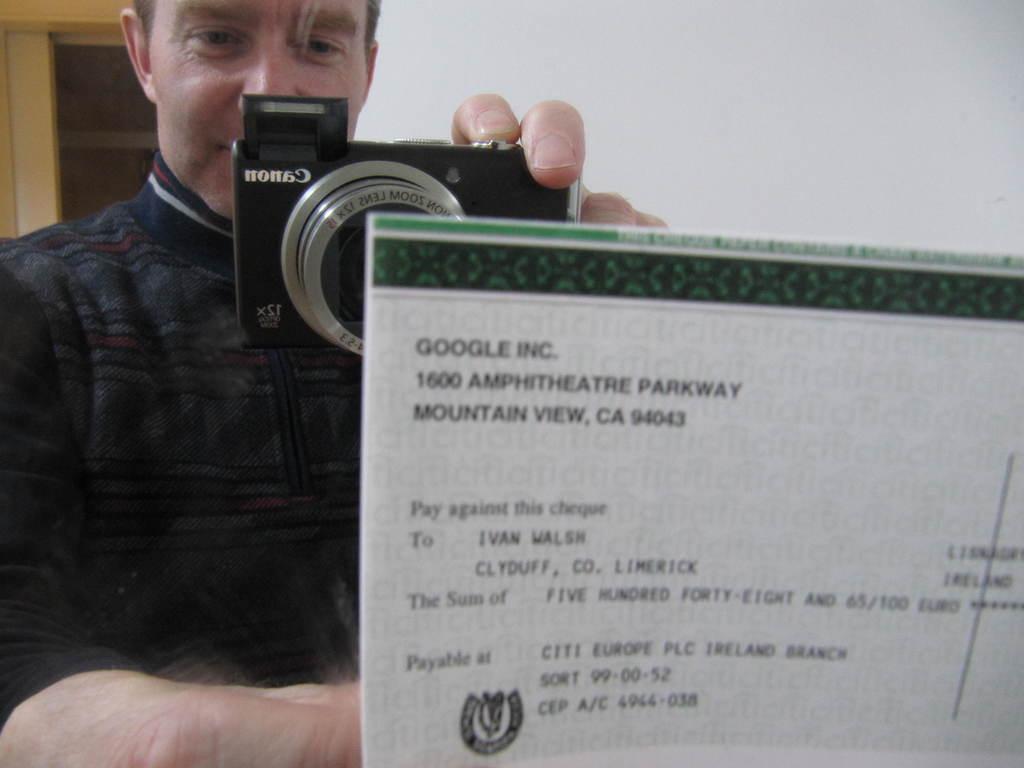How would you summarize this image in a sentence or two? In the image we can see there is a person who is holding camera in front of a paper. 